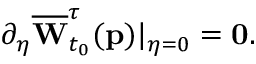Convert formula to latex. <formula><loc_0><loc_0><loc_500><loc_500>\partial _ { \eta } \overline { W } _ { t _ { 0 } } ^ { \tau } ( p ) | _ { \eta = 0 } = 0 .</formula> 